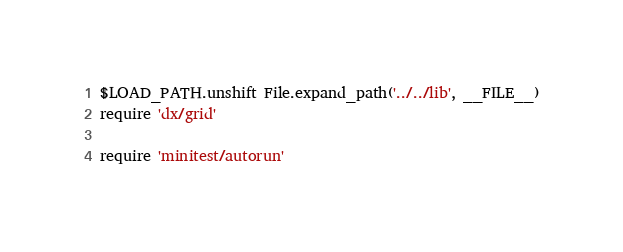Convert code to text. <code><loc_0><loc_0><loc_500><loc_500><_Ruby_>$LOAD_PATH.unshift File.expand_path('../../lib', __FILE__)
require 'dx/grid'

require 'minitest/autorun'
</code> 